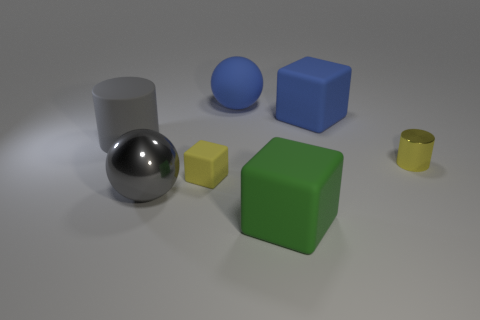Subtract all large rubber cubes. How many cubes are left? 1 Add 1 blue shiny blocks. How many objects exist? 8 Subtract 2 blocks. How many blocks are left? 1 Subtract all blue blocks. How many blocks are left? 2 Subtract all balls. How many objects are left? 5 Subtract all yellow balls. Subtract all gray cylinders. How many balls are left? 2 Add 5 tiny cylinders. How many tiny cylinders are left? 6 Add 5 matte cylinders. How many matte cylinders exist? 6 Subtract 0 yellow spheres. How many objects are left? 7 Subtract all green matte objects. Subtract all big rubber spheres. How many objects are left? 5 